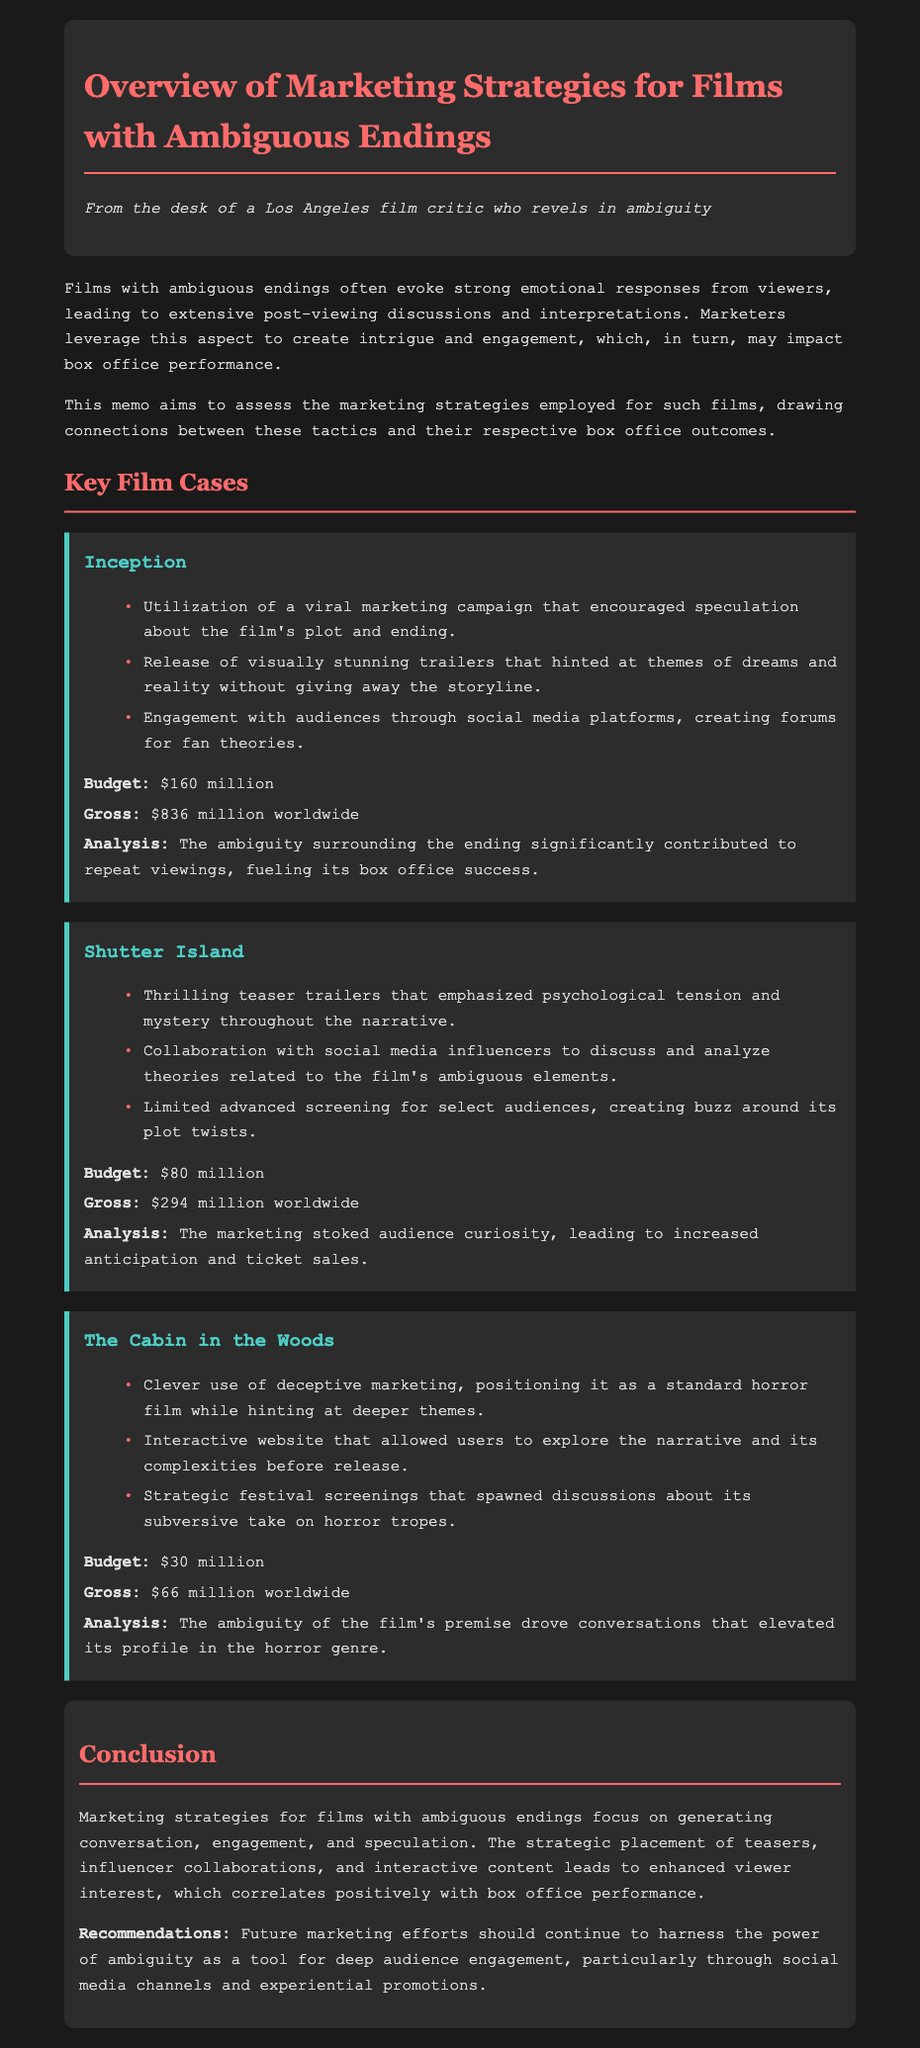what is the title of the memo? The title of the memo is presented at the top of the document, indicating its subject matter.
Answer: Overview of Marketing Strategies for Films with Ambiguous Endings what is the budget of Inception? The budget is specifically mentioned in the performance section for Inception.
Answer: $160 million what marketing strategy was utilized for Shutter Island? The details of marketing strategies for each film are outlined in their respective sections, with Shutter Island including thrilling teaser trailers.
Answer: Thrilling teaser trailers how much did The Cabin in the Woods gross worldwide? The gross revenue is clearly stated in the performance section for The Cabin in the Woods.
Answer: $66 million what correlation is discussed in the conclusion? The conclusion summarizes the findings from the document, focusing on the relationship between engagement and performance.
Answer: Positive correlation with box office performance what type of audience engagement was emphasized for films with ambiguous endings? The document suggests that the marketing strategies are focused on creating specific forms of audience interaction.
Answer: Conversation and speculation which film had the lowest production budget? The budget information is available for all the films discussed, highlighting the differences among them.
Answer: $30 million what kind of website was created for The Cabin in the Woods? The marketing strategies include specific types of media used to engage audiences, with The Cabin in the Woods featuring an interactive website.
Answer: Interactive website 